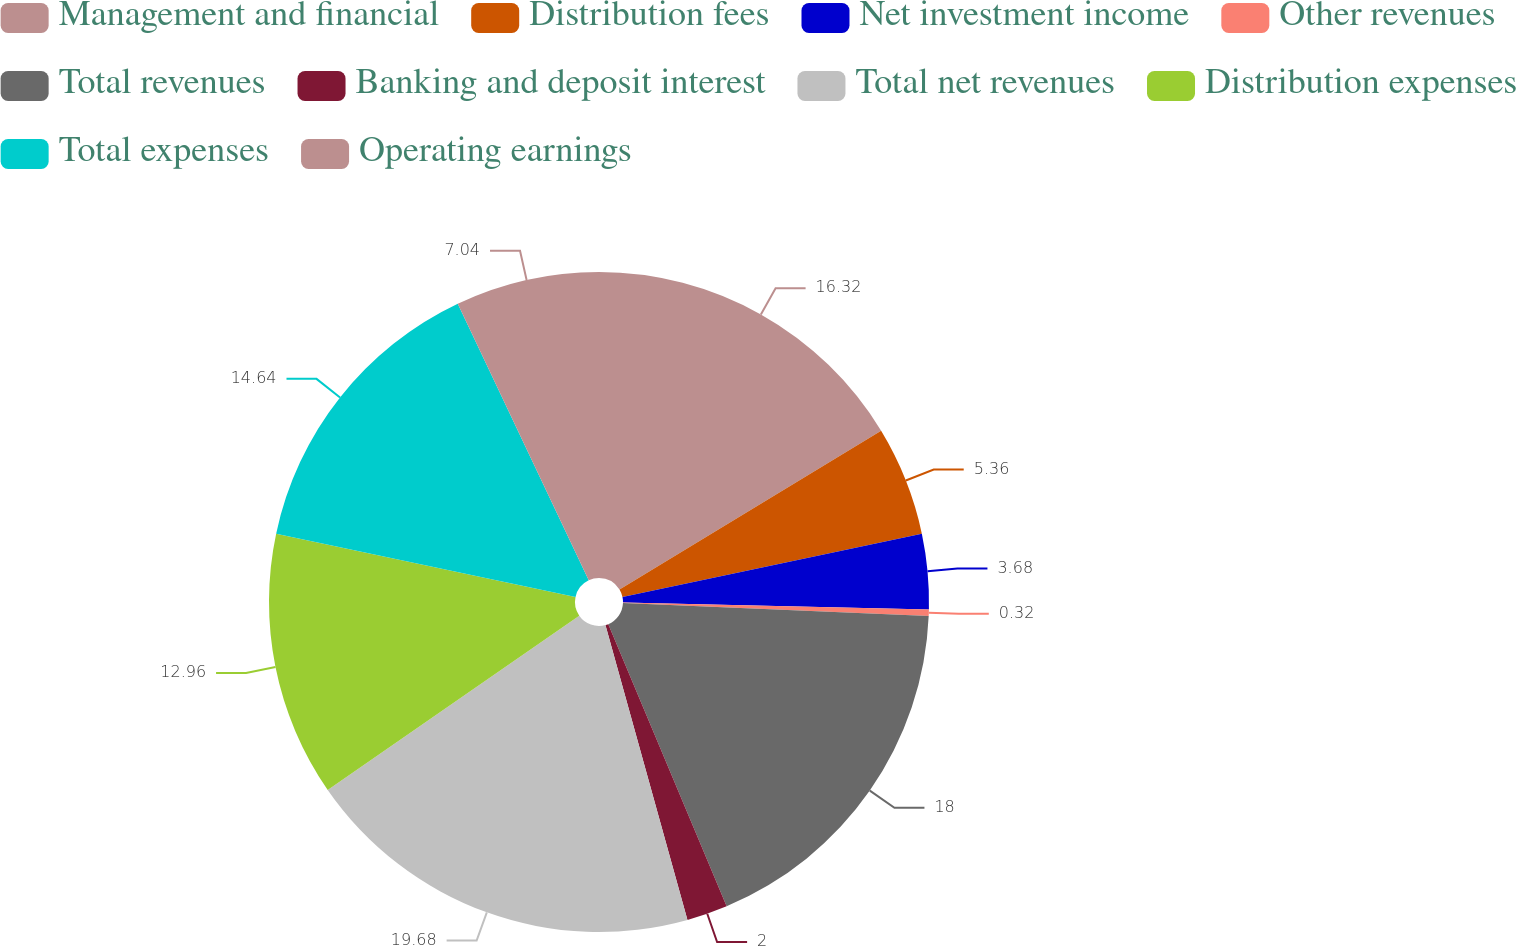<chart> <loc_0><loc_0><loc_500><loc_500><pie_chart><fcel>Management and financial<fcel>Distribution fees<fcel>Net investment income<fcel>Other revenues<fcel>Total revenues<fcel>Banking and deposit interest<fcel>Total net revenues<fcel>Distribution expenses<fcel>Total expenses<fcel>Operating earnings<nl><fcel>16.32%<fcel>5.36%<fcel>3.68%<fcel>0.32%<fcel>18.0%<fcel>2.0%<fcel>19.68%<fcel>12.96%<fcel>14.64%<fcel>7.04%<nl></chart> 